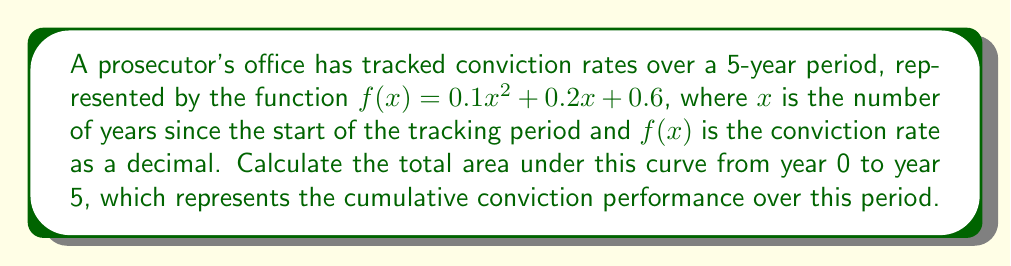Could you help me with this problem? To find the area under the curve, we need to calculate the definite integral of the function $f(x) = 0.1x^2 + 0.2x + 0.6$ from $x=0$ to $x=5$. 

1) First, let's set up the integral:

   $$\int_0^5 (0.1x^2 + 0.2x + 0.6) dx$$

2) Now, we integrate each term:
   
   $$\left[ \frac{0.1x^3}{3} + \frac{0.2x^2}{2} + 0.6x \right]_0^5$$

3) Evaluate the antiderivative at the upper and lower bounds:

   Upper bound (x = 5):
   $$\frac{0.1(5^3)}{3} + \frac{0.2(5^2)}{2} + 0.6(5) = 8.333 + 2.5 + 3 = 13.833$$

   Lower bound (x = 0):
   $$\frac{0.1(0^3)}{3} + \frac{0.2(0^2)}{2} + 0.6(0) = 0 + 0 + 0 = 0$$

4) Subtract the lower bound from the upper bound:

   $$13.833 - 0 = 13.833$$

This result represents the total area under the curve, which in this context can be interpreted as the cumulative conviction performance over the 5-year period.
Answer: The area under the curve is 13.833 conviction-years. 